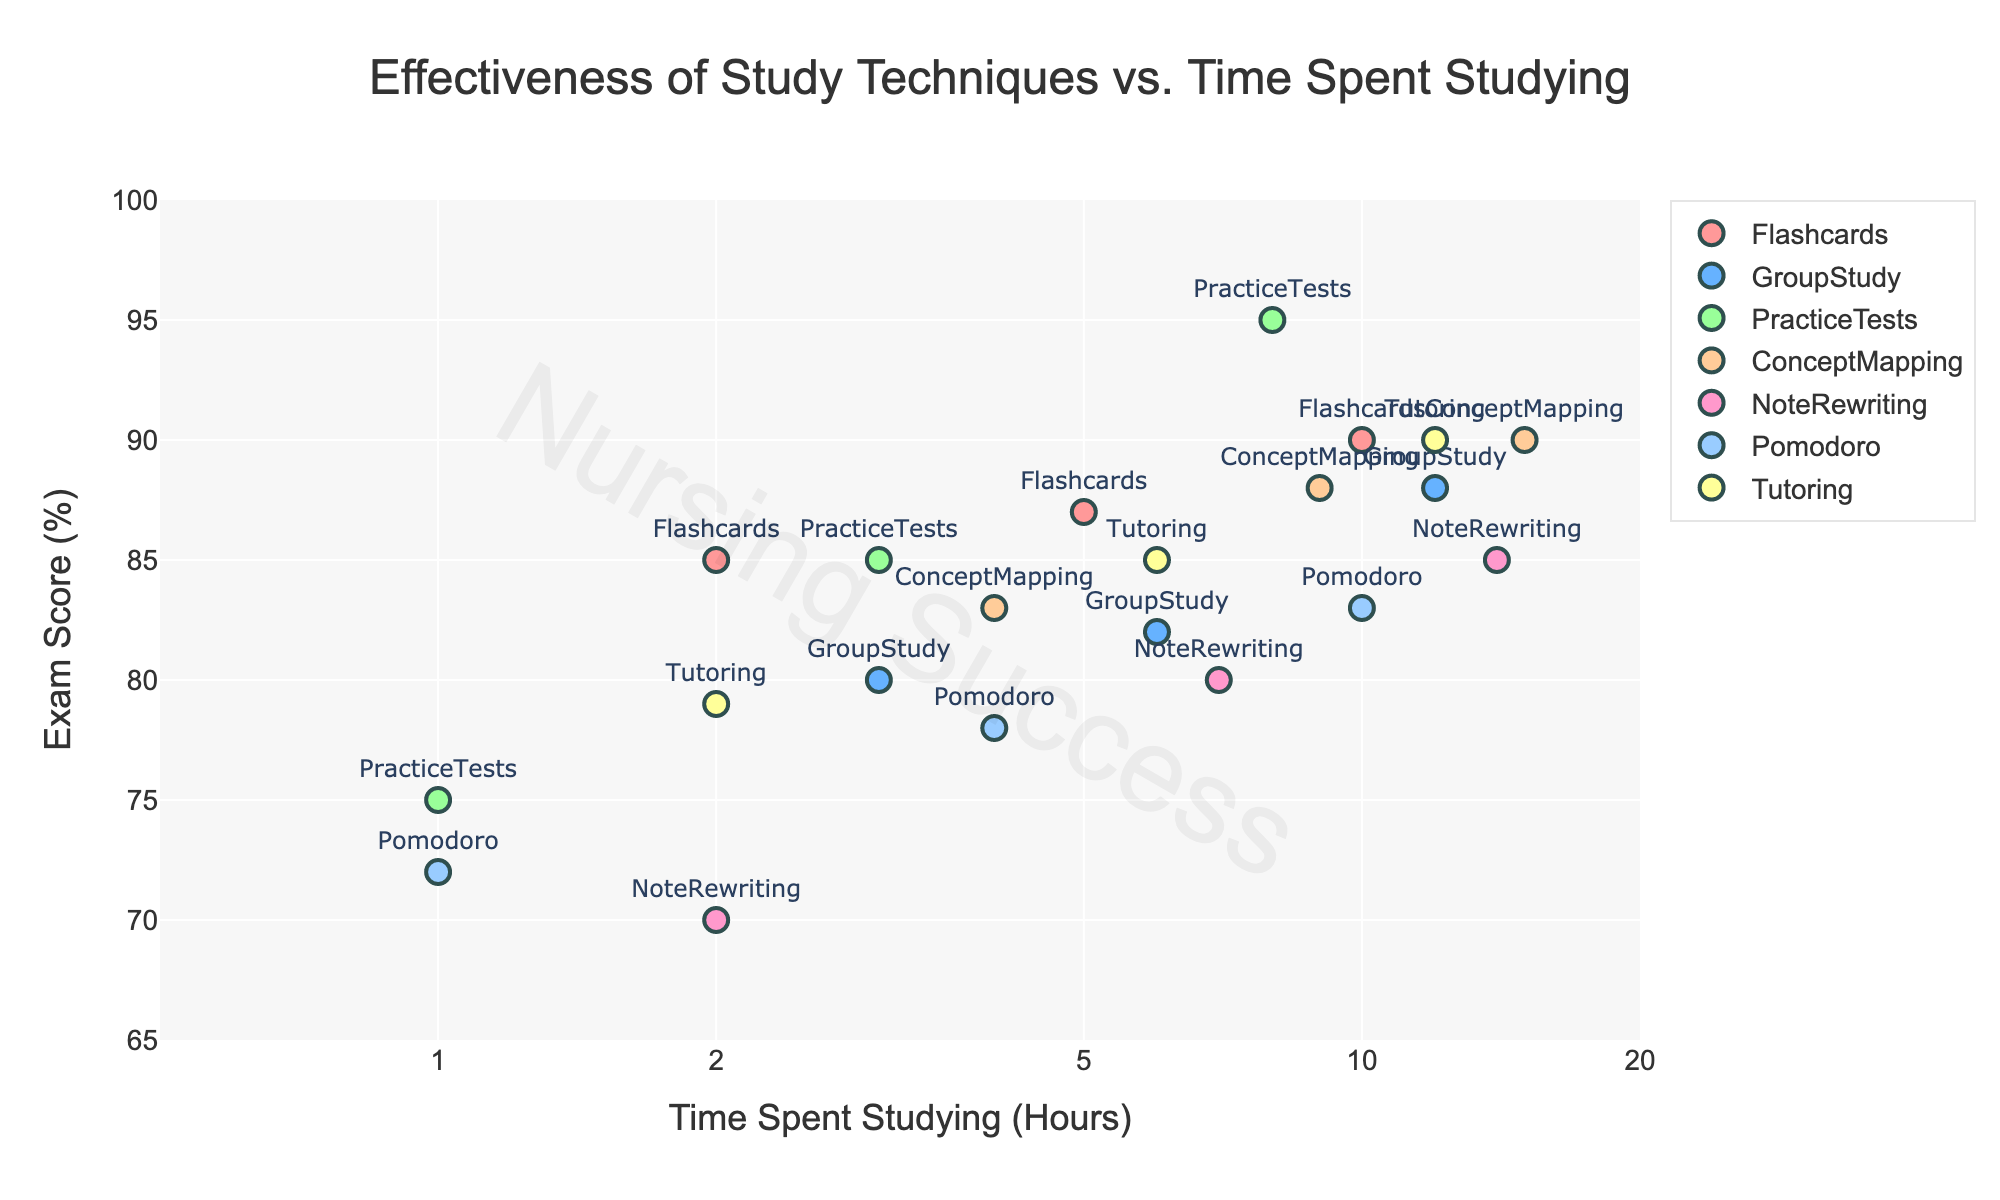What is the title of the figure? The title is displayed at the top center of the figure, showing a large, bold text describing the main topic of the plot. From the visual, we see it reads "Effectiveness of Study Techniques vs. Time Spent Studying".
Answer: Effectiveness of Study Techniques vs. Time Spent Studying How many study techniques are represented in the plot? By counting the unique labels or markers in the legend, you can see there are six study techniques: Flashcards, Group Study, Practice Tests, Concept Mapping, Note Rewriting, and Pomodoro.
Answer: Six Which study technique seems to show the highest exam score with the least amount of time spent studying? By examining the points marked on the leftmost side of the x-axis (log scale), we notice that Practice Tests, with a time spent of 1 hour, got a 75% exam score. This is the highest score among techniques with the least study time.
Answer: Practice Tests What is the relationship between time spent studying and exam score for the Pomodoro technique? Observing the points related to Pomodoro, as time spent studying increases from 1 hour to 10 hours, the exam score also increases from 72% to 83%, showing a positive correlation.
Answer: Positive correlation Which study technique demonstrates the most substantial improvement in exam score as the time spent studying increases? By comparing the slopes of the markers for the study techniques, we observe that Practice Tests show a significant improvement. Starting from 75% at 1 hour up to 95% at 8 hours, indicating the steepest increase.
Answer: Practice Tests At 12 hours of studying, which technique shows the highest exam score and what is it? Find the point with 12 hours on the x-axis; the topmost point on the y-axis is for Practice Tests, which has an exam score of 95%.
Answer: Practice Tests, 95% If a student wants to achieve at least 85% on their exam but can only spend 4 hours studying, which techniques would be suitable based on the plot? Evaluate the points for 4 hours on the x-axis; Flashcards (87%), Practice Tests (85%), and Concept Mapping (83%) are options. The first two meet the score requirement, thus Flashcards and Practice Tests are suitable.
Answer: Flashcards and Practice Tests Comparing Concept Mapping and Note Rewriting techniques, which shows a more consistent exam score increase with increased study time? Comparing the markers for both techniques, Concept Mapping has a smoother and more consistent upward trend, whereas Note Rewriting shows a less consistent pattern.
Answer: Concept Mapping What is the average exam score for the Group Study technique? The exam scores for Group Study are 80%, 82%, and 88%. Adding them gives 250%, and dividing by 3 provides the average: 250 / 3 = 83.33%.
Answer: 83.33% 